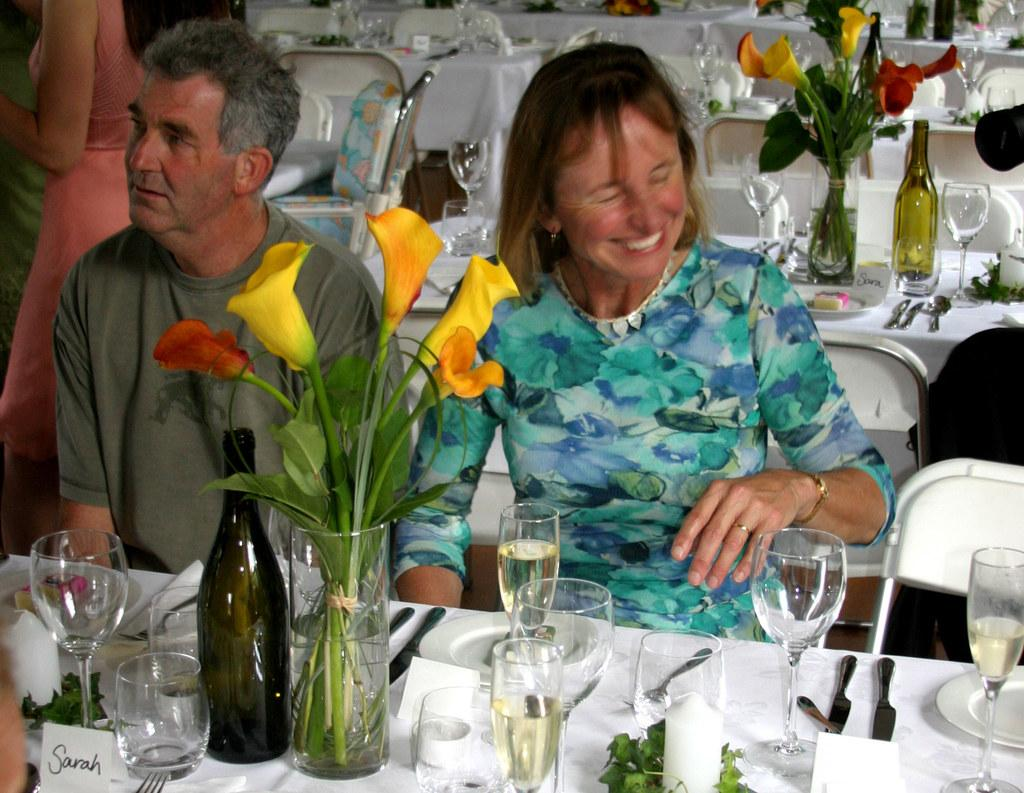How many people are in the image? There are three people in the image. What type of furniture is present in the image? There are chairs and tables in the image. What items can be seen on the table? There is a flask, a flower, a bottle, glasses, spoons, and forks on the table. What type of car is parked near the table in the image? There is no car present in the image. Can you see a badge on any of the people in the image? There is no mention of a badge or any indication that someone is wearing one in the image. 